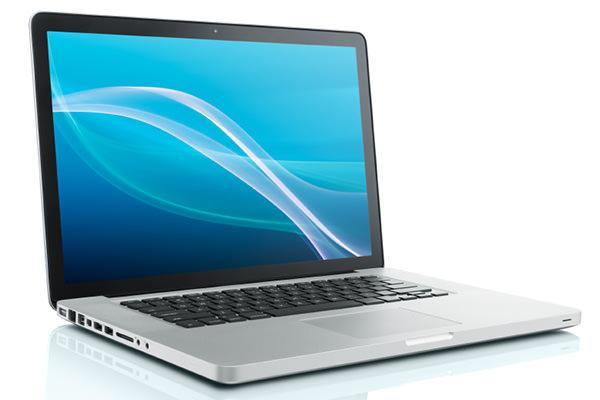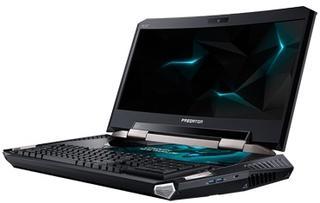The first image is the image on the left, the second image is the image on the right. Considering the images on both sides, is "One of the images contains a laptop turned toward the right." valid? Answer yes or no. Yes. 